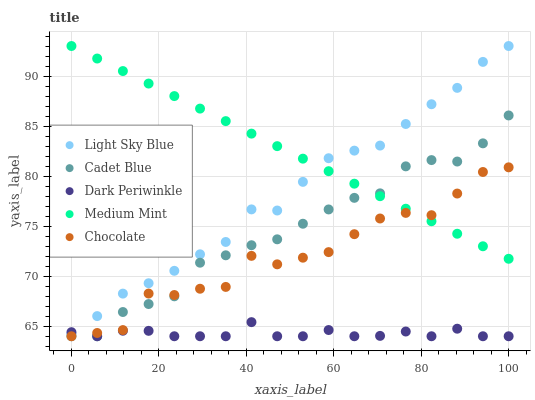Does Dark Periwinkle have the minimum area under the curve?
Answer yes or no. Yes. Does Medium Mint have the maximum area under the curve?
Answer yes or no. Yes. Does Light Sky Blue have the minimum area under the curve?
Answer yes or no. No. Does Light Sky Blue have the maximum area under the curve?
Answer yes or no. No. Is Medium Mint the smoothest?
Answer yes or no. Yes. Is Chocolate the roughest?
Answer yes or no. Yes. Is Light Sky Blue the smoothest?
Answer yes or no. No. Is Light Sky Blue the roughest?
Answer yes or no. No. Does Cadet Blue have the lowest value?
Answer yes or no. Yes. Does Light Sky Blue have the lowest value?
Answer yes or no. No. Does Light Sky Blue have the highest value?
Answer yes or no. Yes. Does Dark Periwinkle have the highest value?
Answer yes or no. No. Is Dark Periwinkle less than Medium Mint?
Answer yes or no. Yes. Is Light Sky Blue greater than Cadet Blue?
Answer yes or no. Yes. Does Cadet Blue intersect Medium Mint?
Answer yes or no. Yes. Is Cadet Blue less than Medium Mint?
Answer yes or no. No. Is Cadet Blue greater than Medium Mint?
Answer yes or no. No. Does Dark Periwinkle intersect Medium Mint?
Answer yes or no. No. 